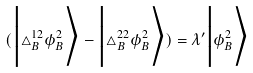Convert formula to latex. <formula><loc_0><loc_0><loc_500><loc_500>( \Big | \triangle _ { B } ^ { 1 2 } \phi ^ { 2 } _ { B } \Big > - \Big | \triangle _ { B } ^ { 2 2 } \phi ^ { 2 } _ { B } \Big > ) = \lambda ^ { \prime } \Big | \phi ^ { 2 } _ { B } \Big ></formula> 